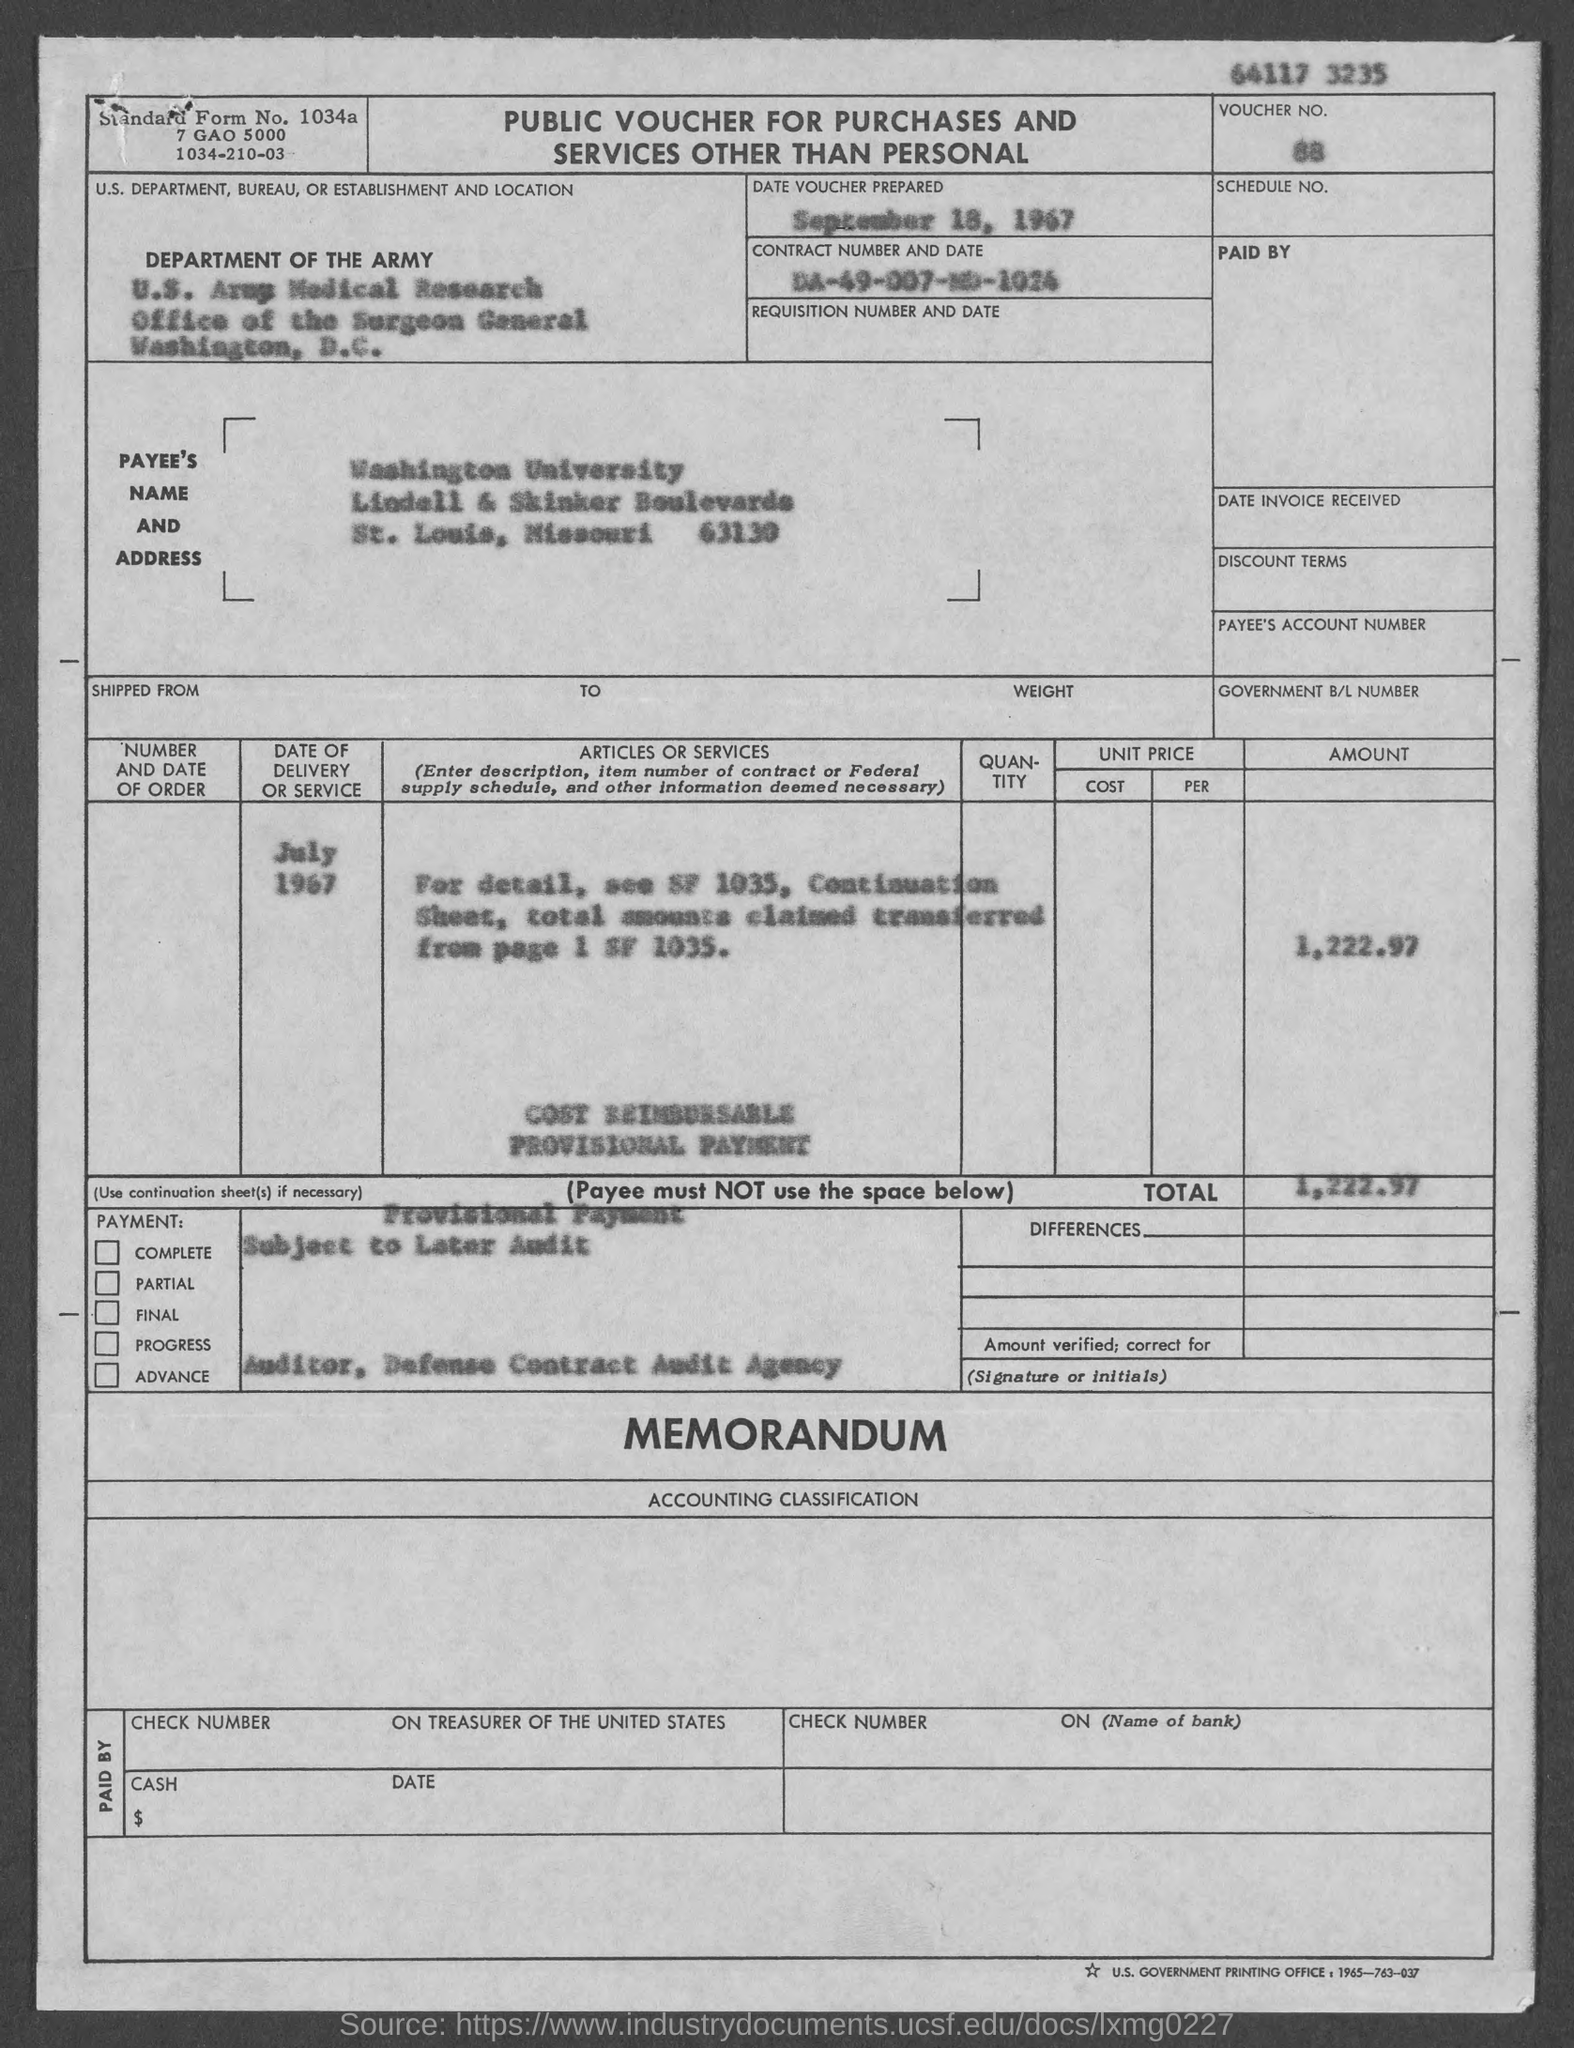What is the voucher no.?
Provide a succinct answer. 88. What is the total?
Ensure brevity in your answer.  1,222.97. In which state is washington university at?
Offer a very short reply. Missouri. On what date is voucher prepared ?
Your answer should be compact. September 18, 1967. In which city is office of the surgeon general at ?
Offer a terse response. Washington. What is the standard form no.?
Ensure brevity in your answer.  1034a. 